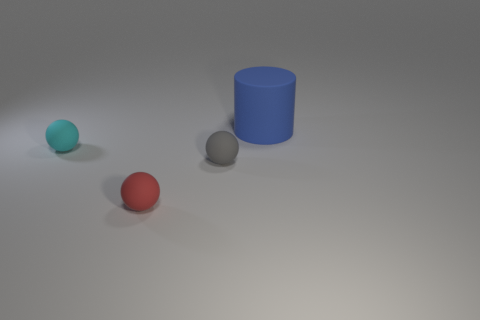If the red sphere were to roll towards the blue cylinder, which direction would it go? If the red sphere were to roll towards the blue cylinder, it would move to the right from its current position in the image, as the blue cylinder is located to the right of the red sphere. 